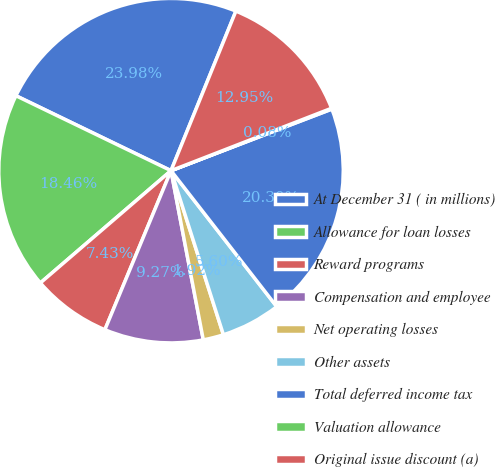Convert chart to OTSL. <chart><loc_0><loc_0><loc_500><loc_500><pie_chart><fcel>At December 31 ( in millions)<fcel>Allowance for loan losses<fcel>Reward programs<fcel>Compensation and employee<fcel>Net operating losses<fcel>Other assets<fcel>Total deferred income tax<fcel>Valuation allowance<fcel>Original issue discount (a)<nl><fcel>23.98%<fcel>18.46%<fcel>7.43%<fcel>9.27%<fcel>1.92%<fcel>5.6%<fcel>20.3%<fcel>0.08%<fcel>12.95%<nl></chart> 